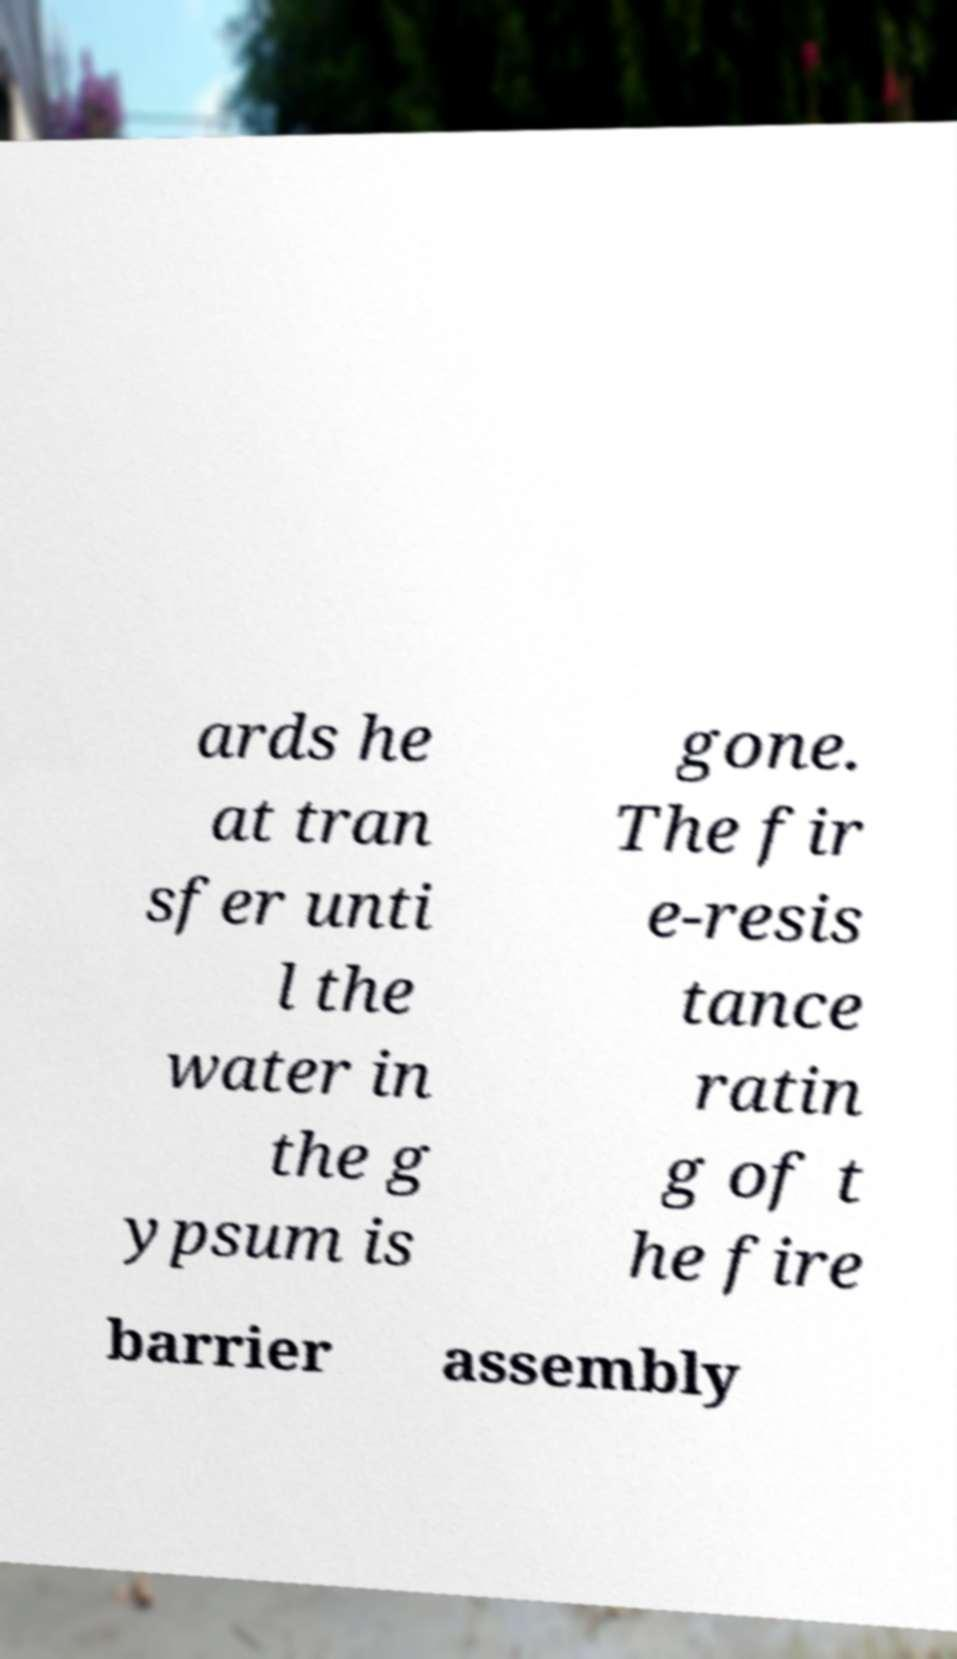Can you read and provide the text displayed in the image?This photo seems to have some interesting text. Can you extract and type it out for me? ards he at tran sfer unti l the water in the g ypsum is gone. The fir e-resis tance ratin g of t he fire barrier assembly 